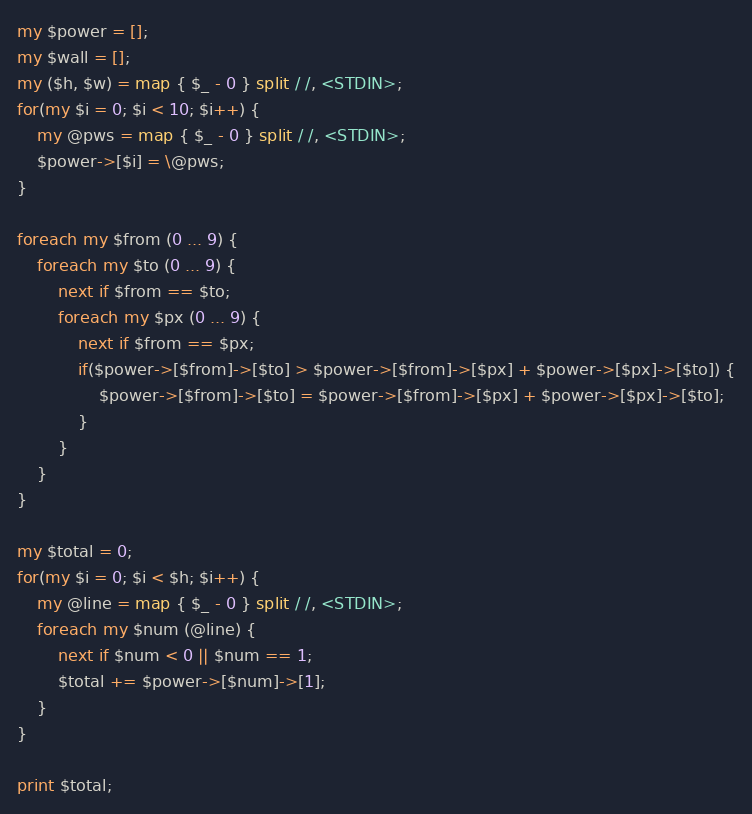<code> <loc_0><loc_0><loc_500><loc_500><_Perl_>my $power = [];
my $wall = [];
my ($h, $w) = map { $_ - 0 } split / /, <STDIN>;
for(my $i = 0; $i < 10; $i++) {
    my @pws = map { $_ - 0 } split / /, <STDIN>;
    $power->[$i] = \@pws;
}

foreach my $from (0 ... 9) {
    foreach my $to (0 ... 9) {
        next if $from == $to;
        foreach my $px (0 ... 9) {
            next if $from == $px;
            if($power->[$from]->[$to] > $power->[$from]->[$px] + $power->[$px]->[$to]) {
                $power->[$from]->[$to] = $power->[$from]->[$px] + $power->[$px]->[$to];
            }
        }
    }
}

my $total = 0;
for(my $i = 0; $i < $h; $i++) {
    my @line = map { $_ - 0 } split / /, <STDIN>;
    foreach my $num (@line) {
        next if $num < 0 || $num == 1;
        $total += $power->[$num]->[1];
    }
}

print $total;</code> 